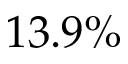Convert formula to latex. <formula><loc_0><loc_0><loc_500><loc_500>1 3 . 9 \%</formula> 